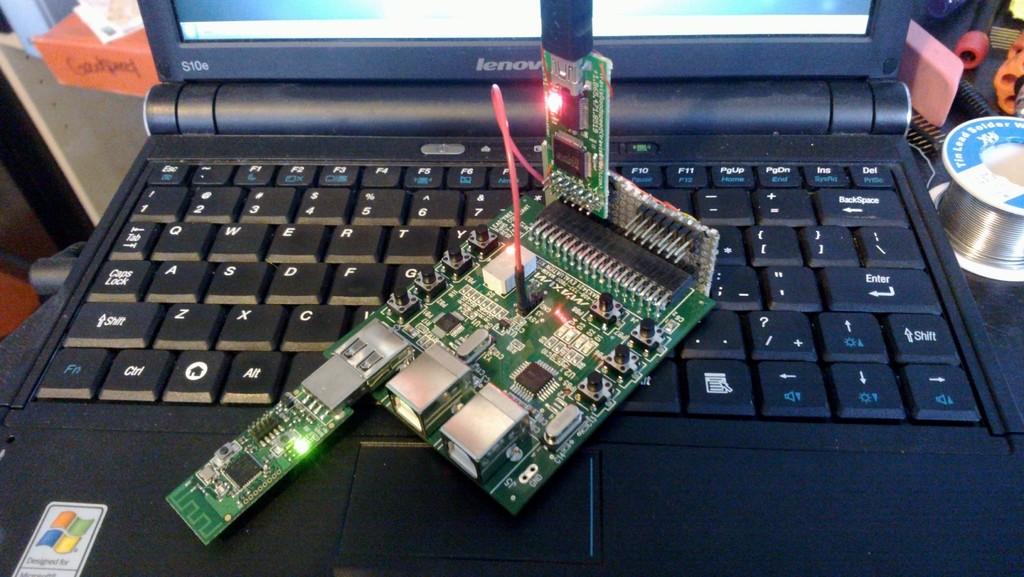What brand of laptop is in the photo?
Offer a terse response. Lenovo. What key is closest to the green computer piece on the bottom row?
Keep it short and to the point. Alt. 